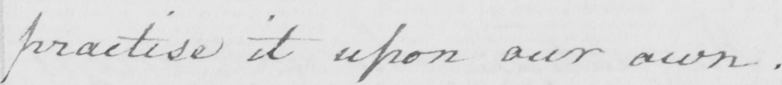What is written in this line of handwriting? practise it upon our own  . 